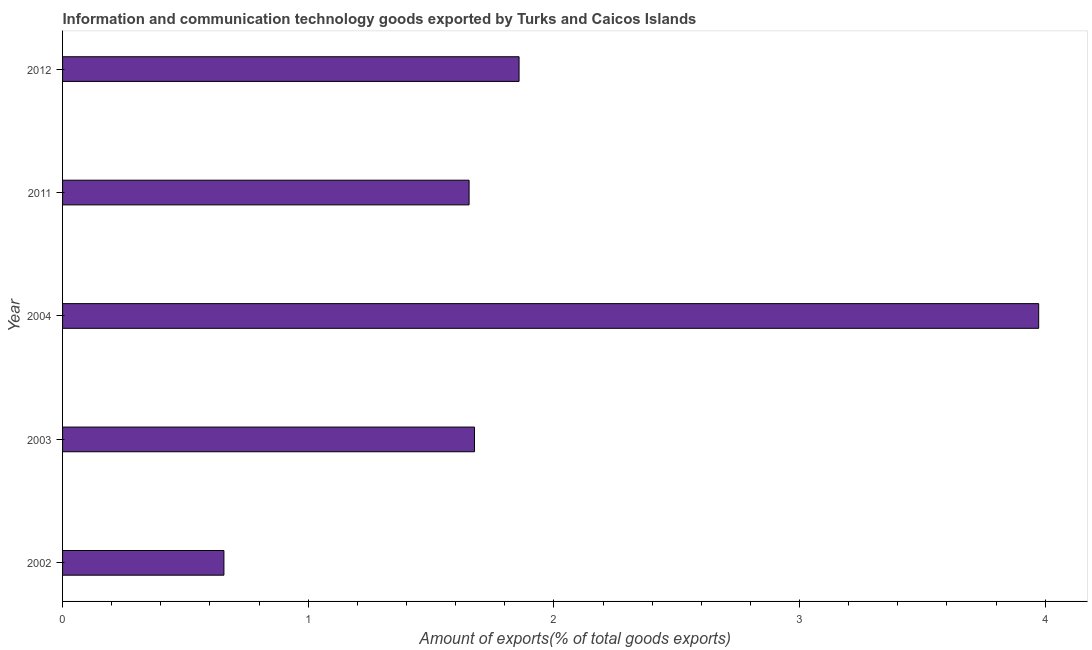Does the graph contain any zero values?
Provide a short and direct response. No. Does the graph contain grids?
Provide a short and direct response. No. What is the title of the graph?
Offer a very short reply. Information and communication technology goods exported by Turks and Caicos Islands. What is the label or title of the X-axis?
Offer a very short reply. Amount of exports(% of total goods exports). What is the amount of ict goods exports in 2012?
Provide a short and direct response. 1.86. Across all years, what is the maximum amount of ict goods exports?
Your answer should be compact. 3.97. Across all years, what is the minimum amount of ict goods exports?
Provide a succinct answer. 0.66. In which year was the amount of ict goods exports minimum?
Keep it short and to the point. 2002. What is the sum of the amount of ict goods exports?
Provide a succinct answer. 9.82. What is the difference between the amount of ict goods exports in 2003 and 2012?
Make the answer very short. -0.18. What is the average amount of ict goods exports per year?
Provide a short and direct response. 1.96. What is the median amount of ict goods exports?
Your answer should be compact. 1.68. Do a majority of the years between 2004 and 2012 (inclusive) have amount of ict goods exports greater than 1.6 %?
Provide a succinct answer. Yes. What is the ratio of the amount of ict goods exports in 2003 to that in 2011?
Offer a very short reply. 1.01. What is the difference between the highest and the second highest amount of ict goods exports?
Ensure brevity in your answer.  2.12. What is the difference between the highest and the lowest amount of ict goods exports?
Keep it short and to the point. 3.32. Are all the bars in the graph horizontal?
Offer a very short reply. Yes. What is the difference between two consecutive major ticks on the X-axis?
Keep it short and to the point. 1. Are the values on the major ticks of X-axis written in scientific E-notation?
Offer a very short reply. No. What is the Amount of exports(% of total goods exports) in 2002?
Make the answer very short. 0.66. What is the Amount of exports(% of total goods exports) in 2003?
Provide a short and direct response. 1.68. What is the Amount of exports(% of total goods exports) of 2004?
Keep it short and to the point. 3.97. What is the Amount of exports(% of total goods exports) in 2011?
Provide a succinct answer. 1.65. What is the Amount of exports(% of total goods exports) of 2012?
Provide a short and direct response. 1.86. What is the difference between the Amount of exports(% of total goods exports) in 2002 and 2003?
Give a very brief answer. -1.02. What is the difference between the Amount of exports(% of total goods exports) in 2002 and 2004?
Provide a succinct answer. -3.32. What is the difference between the Amount of exports(% of total goods exports) in 2002 and 2011?
Your response must be concise. -1. What is the difference between the Amount of exports(% of total goods exports) in 2002 and 2012?
Make the answer very short. -1.2. What is the difference between the Amount of exports(% of total goods exports) in 2003 and 2004?
Give a very brief answer. -2.3. What is the difference between the Amount of exports(% of total goods exports) in 2003 and 2011?
Provide a succinct answer. 0.02. What is the difference between the Amount of exports(% of total goods exports) in 2003 and 2012?
Offer a terse response. -0.18. What is the difference between the Amount of exports(% of total goods exports) in 2004 and 2011?
Keep it short and to the point. 2.32. What is the difference between the Amount of exports(% of total goods exports) in 2004 and 2012?
Your response must be concise. 2.12. What is the difference between the Amount of exports(% of total goods exports) in 2011 and 2012?
Give a very brief answer. -0.2. What is the ratio of the Amount of exports(% of total goods exports) in 2002 to that in 2003?
Your response must be concise. 0.39. What is the ratio of the Amount of exports(% of total goods exports) in 2002 to that in 2004?
Offer a terse response. 0.17. What is the ratio of the Amount of exports(% of total goods exports) in 2002 to that in 2011?
Make the answer very short. 0.4. What is the ratio of the Amount of exports(% of total goods exports) in 2002 to that in 2012?
Offer a terse response. 0.35. What is the ratio of the Amount of exports(% of total goods exports) in 2003 to that in 2004?
Your response must be concise. 0.42. What is the ratio of the Amount of exports(% of total goods exports) in 2003 to that in 2011?
Your answer should be very brief. 1.01. What is the ratio of the Amount of exports(% of total goods exports) in 2003 to that in 2012?
Make the answer very short. 0.9. What is the ratio of the Amount of exports(% of total goods exports) in 2004 to that in 2011?
Ensure brevity in your answer.  2.4. What is the ratio of the Amount of exports(% of total goods exports) in 2004 to that in 2012?
Keep it short and to the point. 2.14. What is the ratio of the Amount of exports(% of total goods exports) in 2011 to that in 2012?
Your answer should be compact. 0.89. 